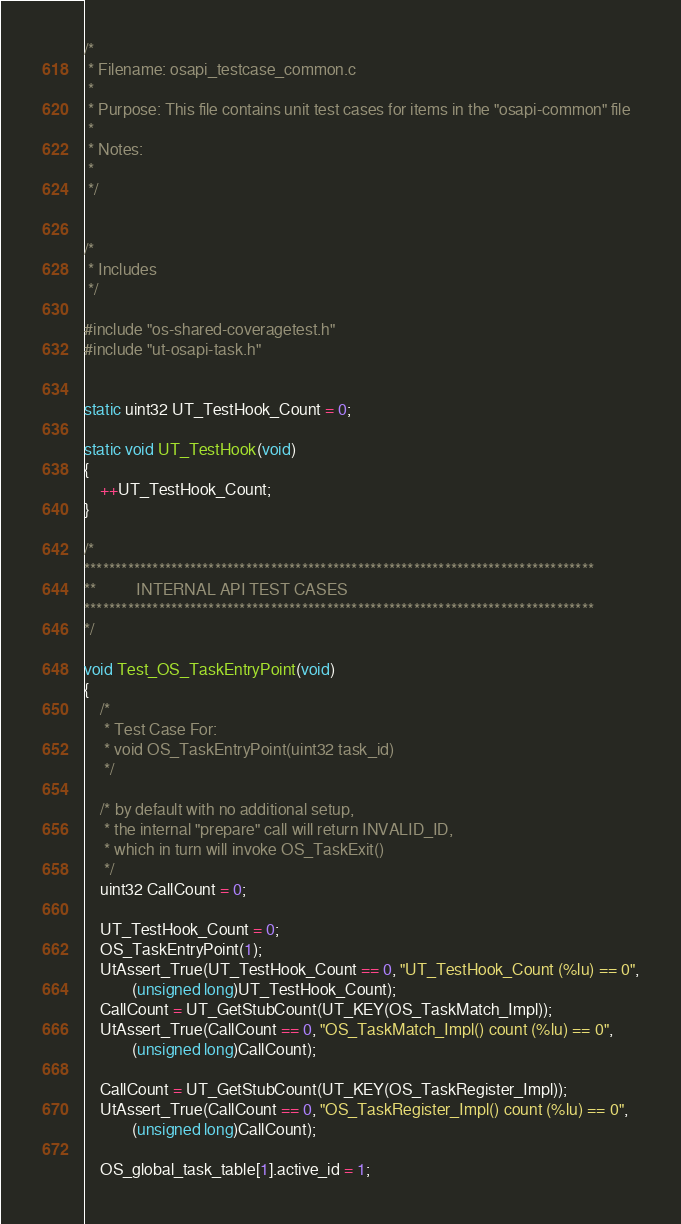Convert code to text. <code><loc_0><loc_0><loc_500><loc_500><_C_>/*
 * Filename: osapi_testcase_common.c
 *
 * Purpose: This file contains unit test cases for items in the "osapi-common" file
 *
 * Notes:
 *
 */


/*
 * Includes
 */

#include "os-shared-coveragetest.h"
#include "ut-osapi-task.h"


static uint32 UT_TestHook_Count = 0;

static void UT_TestHook(void)
{
    ++UT_TestHook_Count;
}

/*
**********************************************************************************
**          INTERNAL API TEST CASES
**********************************************************************************
*/

void Test_OS_TaskEntryPoint(void)
{
    /*
     * Test Case For:
     * void OS_TaskEntryPoint(uint32 task_id)
     */

    /* by default with no additional setup,
     * the internal "prepare" call will return INVALID_ID,
     * which in turn will invoke OS_TaskExit()
     */
    uint32 CallCount = 0;

    UT_TestHook_Count = 0;
    OS_TaskEntryPoint(1);
    UtAssert_True(UT_TestHook_Count == 0, "UT_TestHook_Count (%lu) == 0",
            (unsigned long)UT_TestHook_Count);
    CallCount = UT_GetStubCount(UT_KEY(OS_TaskMatch_Impl));
    UtAssert_True(CallCount == 0, "OS_TaskMatch_Impl() count (%lu) == 0",
            (unsigned long)CallCount);

    CallCount = UT_GetStubCount(UT_KEY(OS_TaskRegister_Impl));
    UtAssert_True(CallCount == 0, "OS_TaskRegister_Impl() count (%lu) == 0",
            (unsigned long)CallCount);

    OS_global_task_table[1].active_id = 1;</code> 